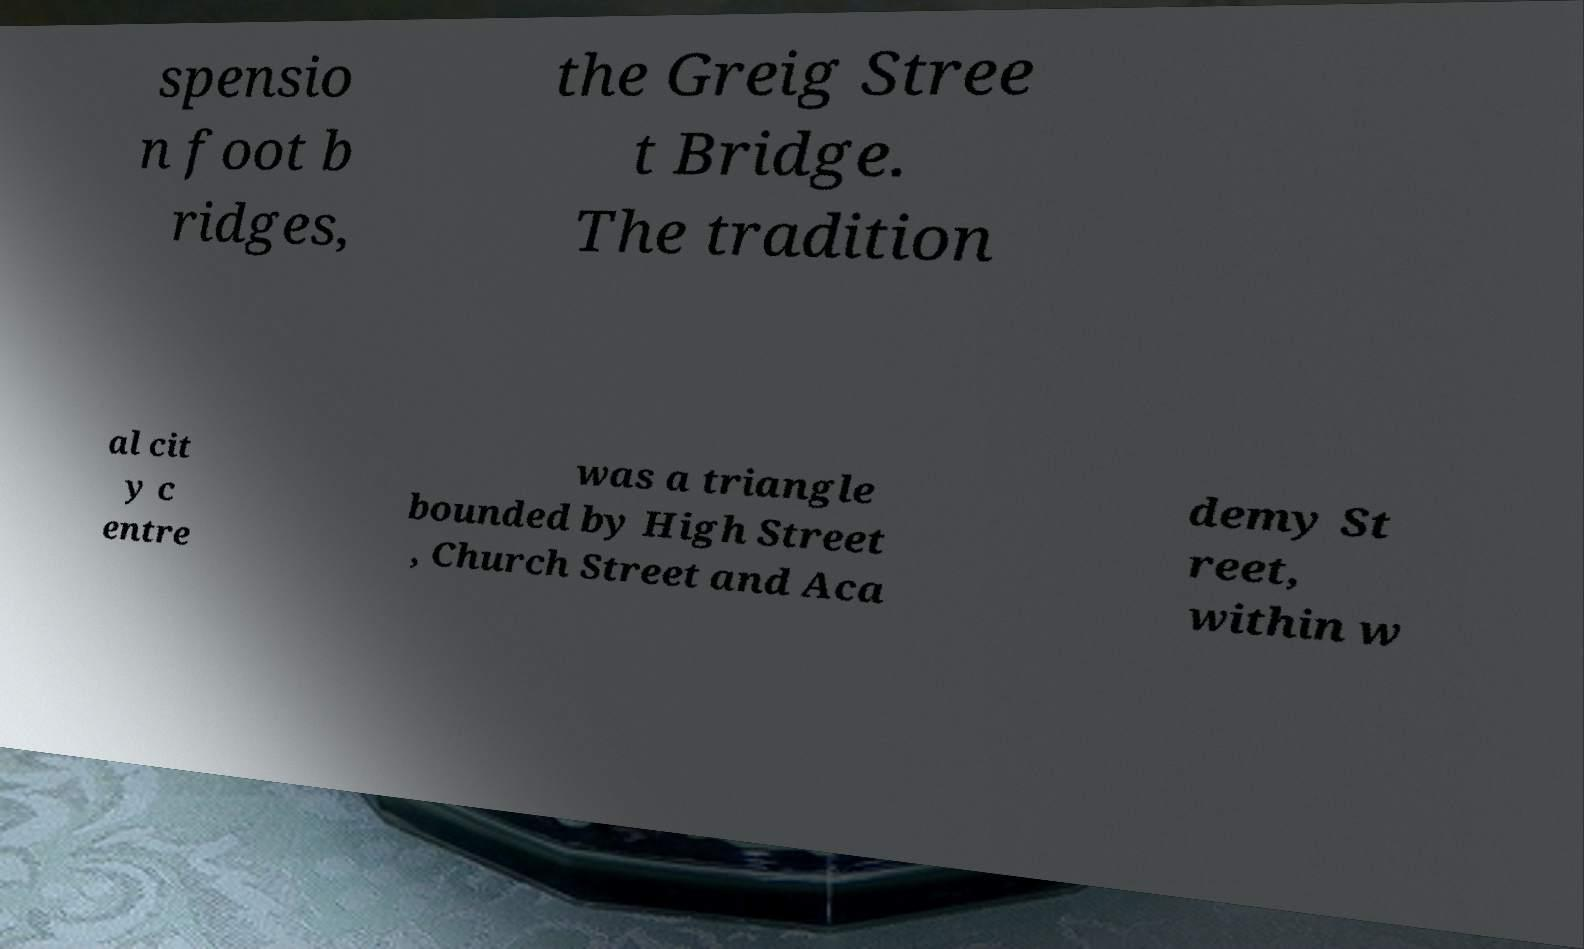Can you accurately transcribe the text from the provided image for me? spensio n foot b ridges, the Greig Stree t Bridge. The tradition al cit y c entre was a triangle bounded by High Street , Church Street and Aca demy St reet, within w 